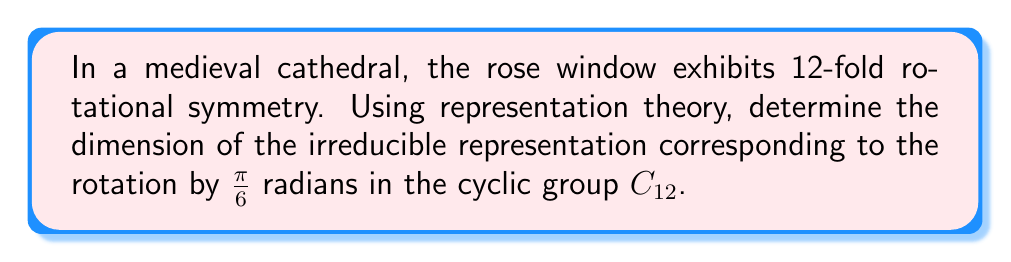Can you answer this question? To solve this problem, we'll follow these steps:

1) First, recall that for a cyclic group $C_n$, there are $n$ irreducible representations, each of dimension 1.

2) These representations are given by the characters:
   $$\chi_k(g^j) = e^{2\pi i k j / n}$$
   where $k = 0, 1, ..., n-1$ and $g$ is the generator of the group.

3) In our case, $n = 12$, and we're interested in the rotation by $\frac{\pi}{6}$ radians, which corresponds to $g^1$ (one-twelfth of a full rotation).

4) So, we need to calculate:
   $$\chi_k(g^1) = e^{2\pi i k / 12}$$

5) This gives us a complex number on the unit circle for each $k$.

6) The dimension of an irreducible representation is always the absolute value of its character.

7) Since $e^{2\pi i k / 12}$ is always on the unit circle, its absolute value is always 1.

Therefore, regardless of which irreducible representation we choose (i.e., regardless of the value of $k$), the dimension will always be 1.

This result aligns with the historical context: in medieval architecture, symmetry was often used to represent divine perfection, with each element having singular significance.
Answer: 1 